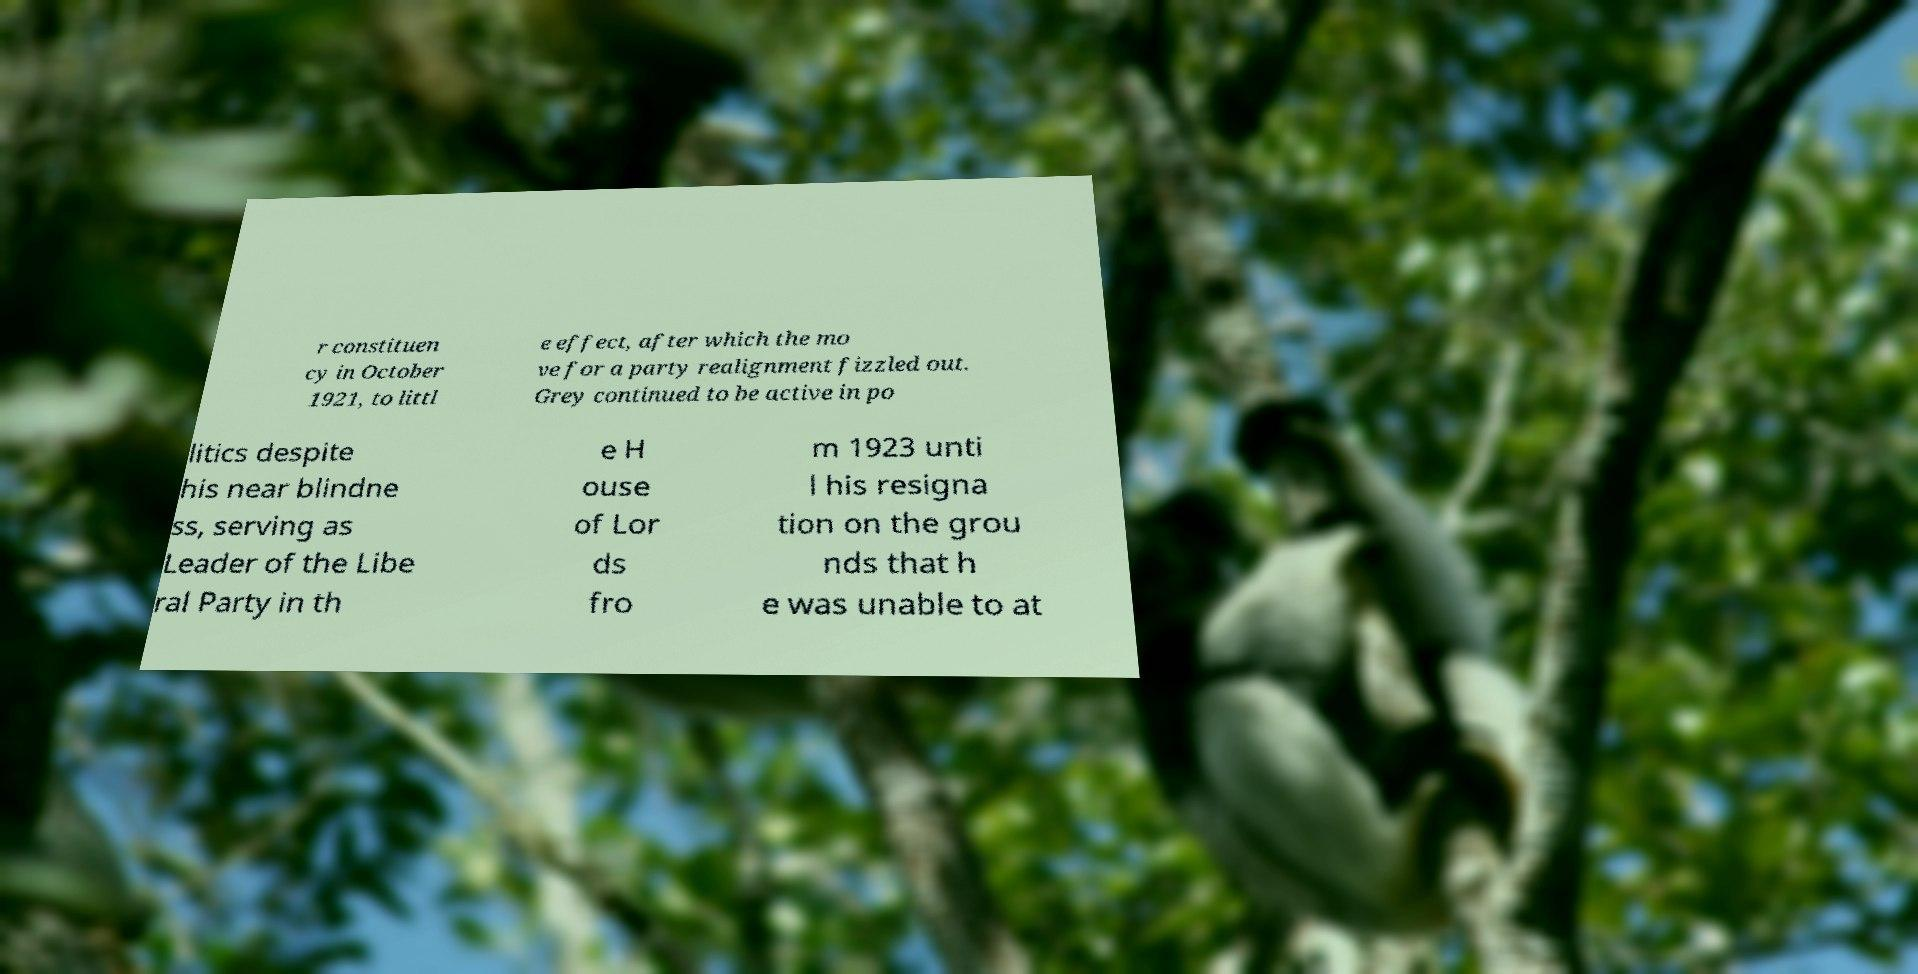There's text embedded in this image that I need extracted. Can you transcribe it verbatim? r constituen cy in October 1921, to littl e effect, after which the mo ve for a party realignment fizzled out. Grey continued to be active in po litics despite his near blindne ss, serving as Leader of the Libe ral Party in th e H ouse of Lor ds fro m 1923 unti l his resigna tion on the grou nds that h e was unable to at 